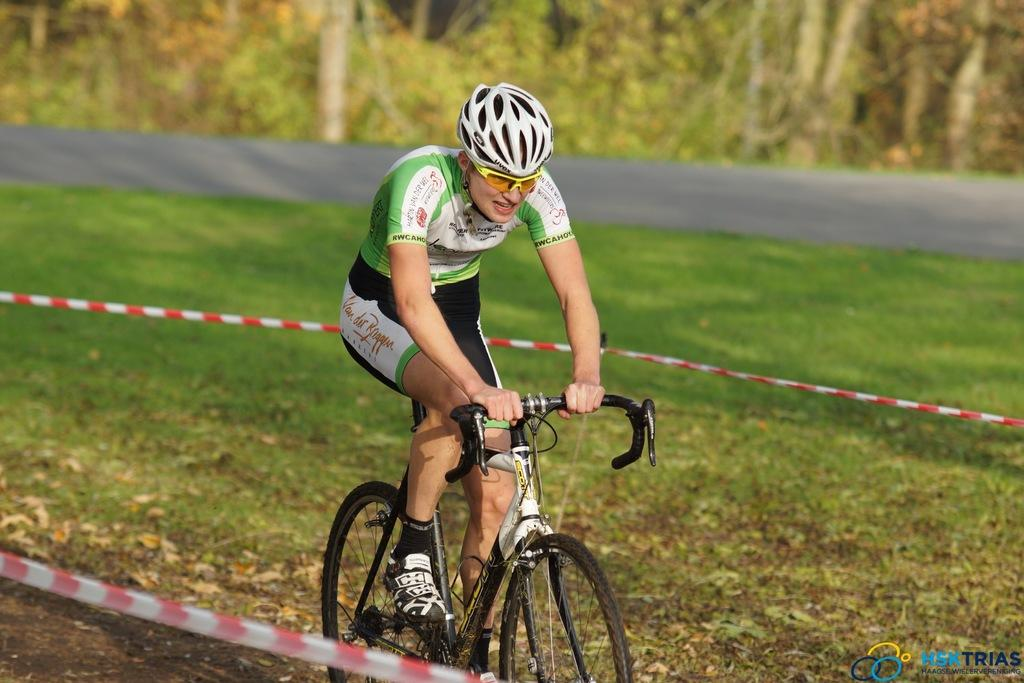What is the person in the image doing? There is a person riding a bicycle in the image. What other objects or elements can be seen in the image? There are ribbons in the image. What can be seen in the background of the image? There are trees, a road, and grass in the background of the image. What type of apple is being used as a system to control the bicycle in the image? There is no apple or system present in the image to control the bicycle; it is being ridden by a person. 